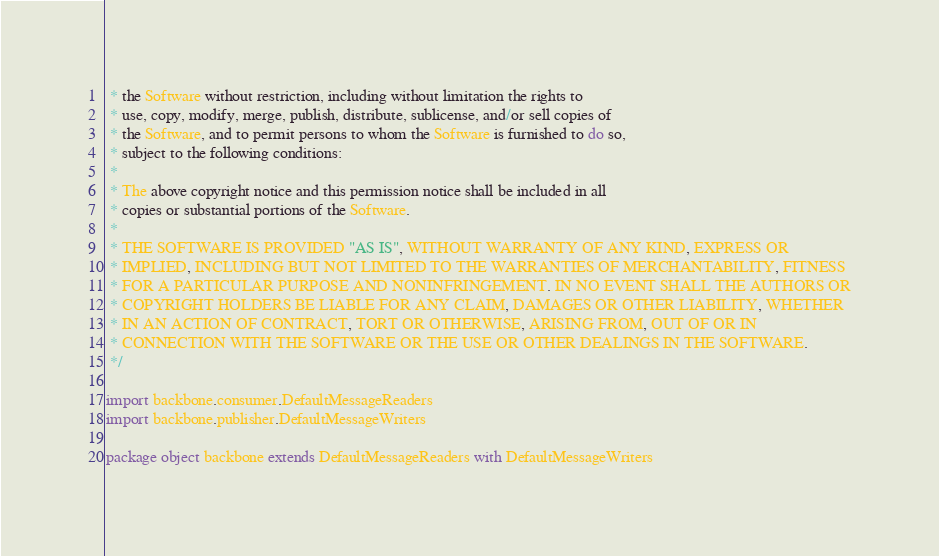Convert code to text. <code><loc_0><loc_0><loc_500><loc_500><_Scala_> * the Software without restriction, including without limitation the rights to
 * use, copy, modify, merge, publish, distribute, sublicense, and/or sell copies of
 * the Software, and to permit persons to whom the Software is furnished to do so,
 * subject to the following conditions:
 *
 * The above copyright notice and this permission notice shall be included in all
 * copies or substantial portions of the Software.
 *
 * THE SOFTWARE IS PROVIDED "AS IS", WITHOUT WARRANTY OF ANY KIND, EXPRESS OR
 * IMPLIED, INCLUDING BUT NOT LIMITED TO THE WARRANTIES OF MERCHANTABILITY, FITNESS
 * FOR A PARTICULAR PURPOSE AND NONINFRINGEMENT. IN NO EVENT SHALL THE AUTHORS OR
 * COPYRIGHT HOLDERS BE LIABLE FOR ANY CLAIM, DAMAGES OR OTHER LIABILITY, WHETHER
 * IN AN ACTION OF CONTRACT, TORT OR OTHERWISE, ARISING FROM, OUT OF OR IN
 * CONNECTION WITH THE SOFTWARE OR THE USE OR OTHER DEALINGS IN THE SOFTWARE.
 */

import backbone.consumer.DefaultMessageReaders
import backbone.publisher.DefaultMessageWriters

package object backbone extends DefaultMessageReaders with DefaultMessageWriters
</code> 